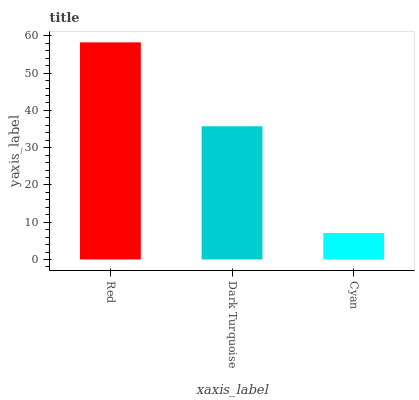Is Cyan the minimum?
Answer yes or no. Yes. Is Red the maximum?
Answer yes or no. Yes. Is Dark Turquoise the minimum?
Answer yes or no. No. Is Dark Turquoise the maximum?
Answer yes or no. No. Is Red greater than Dark Turquoise?
Answer yes or no. Yes. Is Dark Turquoise less than Red?
Answer yes or no. Yes. Is Dark Turquoise greater than Red?
Answer yes or no. No. Is Red less than Dark Turquoise?
Answer yes or no. No. Is Dark Turquoise the high median?
Answer yes or no. Yes. Is Dark Turquoise the low median?
Answer yes or no. Yes. Is Red the high median?
Answer yes or no. No. Is Cyan the low median?
Answer yes or no. No. 